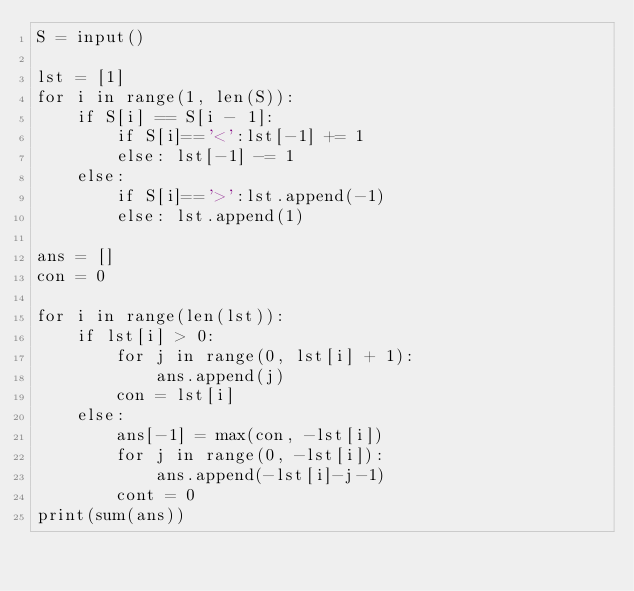<code> <loc_0><loc_0><loc_500><loc_500><_Python_>S = input()

lst = [1]
for i in range(1, len(S)):
    if S[i] == S[i - 1]:
        if S[i]=='<':lst[-1] += 1
        else: lst[-1] -= 1
    else:
        if S[i]=='>':lst.append(-1)
        else: lst.append(1)

ans = []
con = 0

for i in range(len(lst)):
    if lst[i] > 0:
        for j in range(0, lst[i] + 1):
            ans.append(j)
        con = lst[i]
    else:
        ans[-1] = max(con, -lst[i])
        for j in range(0, -lst[i]):
            ans.append(-lst[i]-j-1)
        cont = 0
print(sum(ans))</code> 